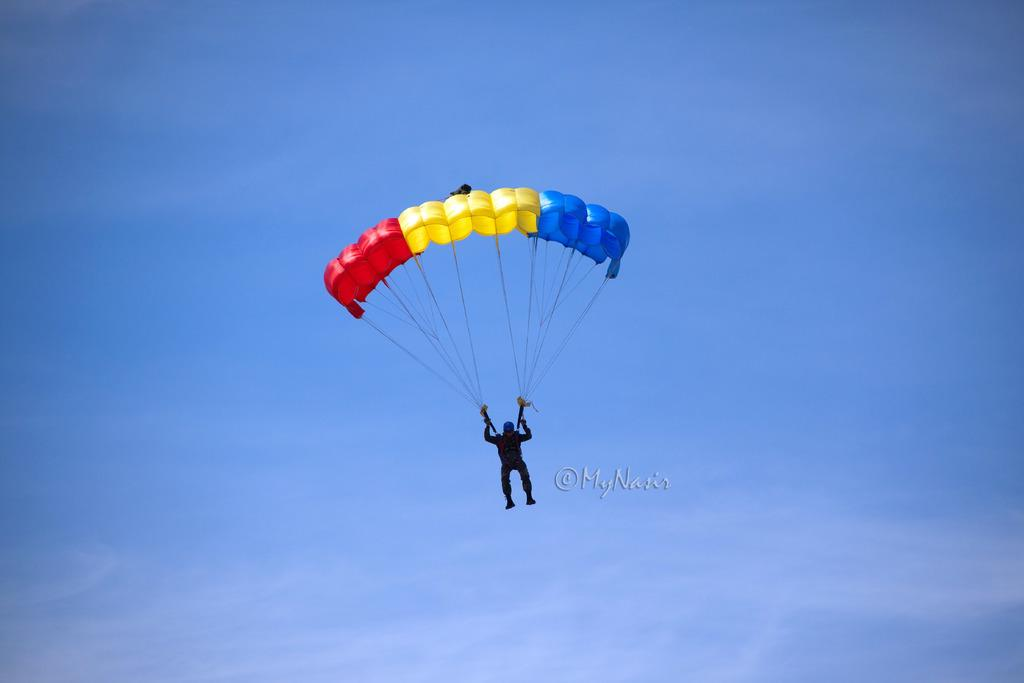What is happening to the person in the image? The person is flying in the air. How is the person able to fly in the air? The person is using a parachute. What can be seen in the background of the image? The sky is visible in the image, and clouds are present in the sky. Where is the faucet located in the image? There is no faucet present in the image. What type of tax is being discussed in the image? There is no discussion of tax in the image. 